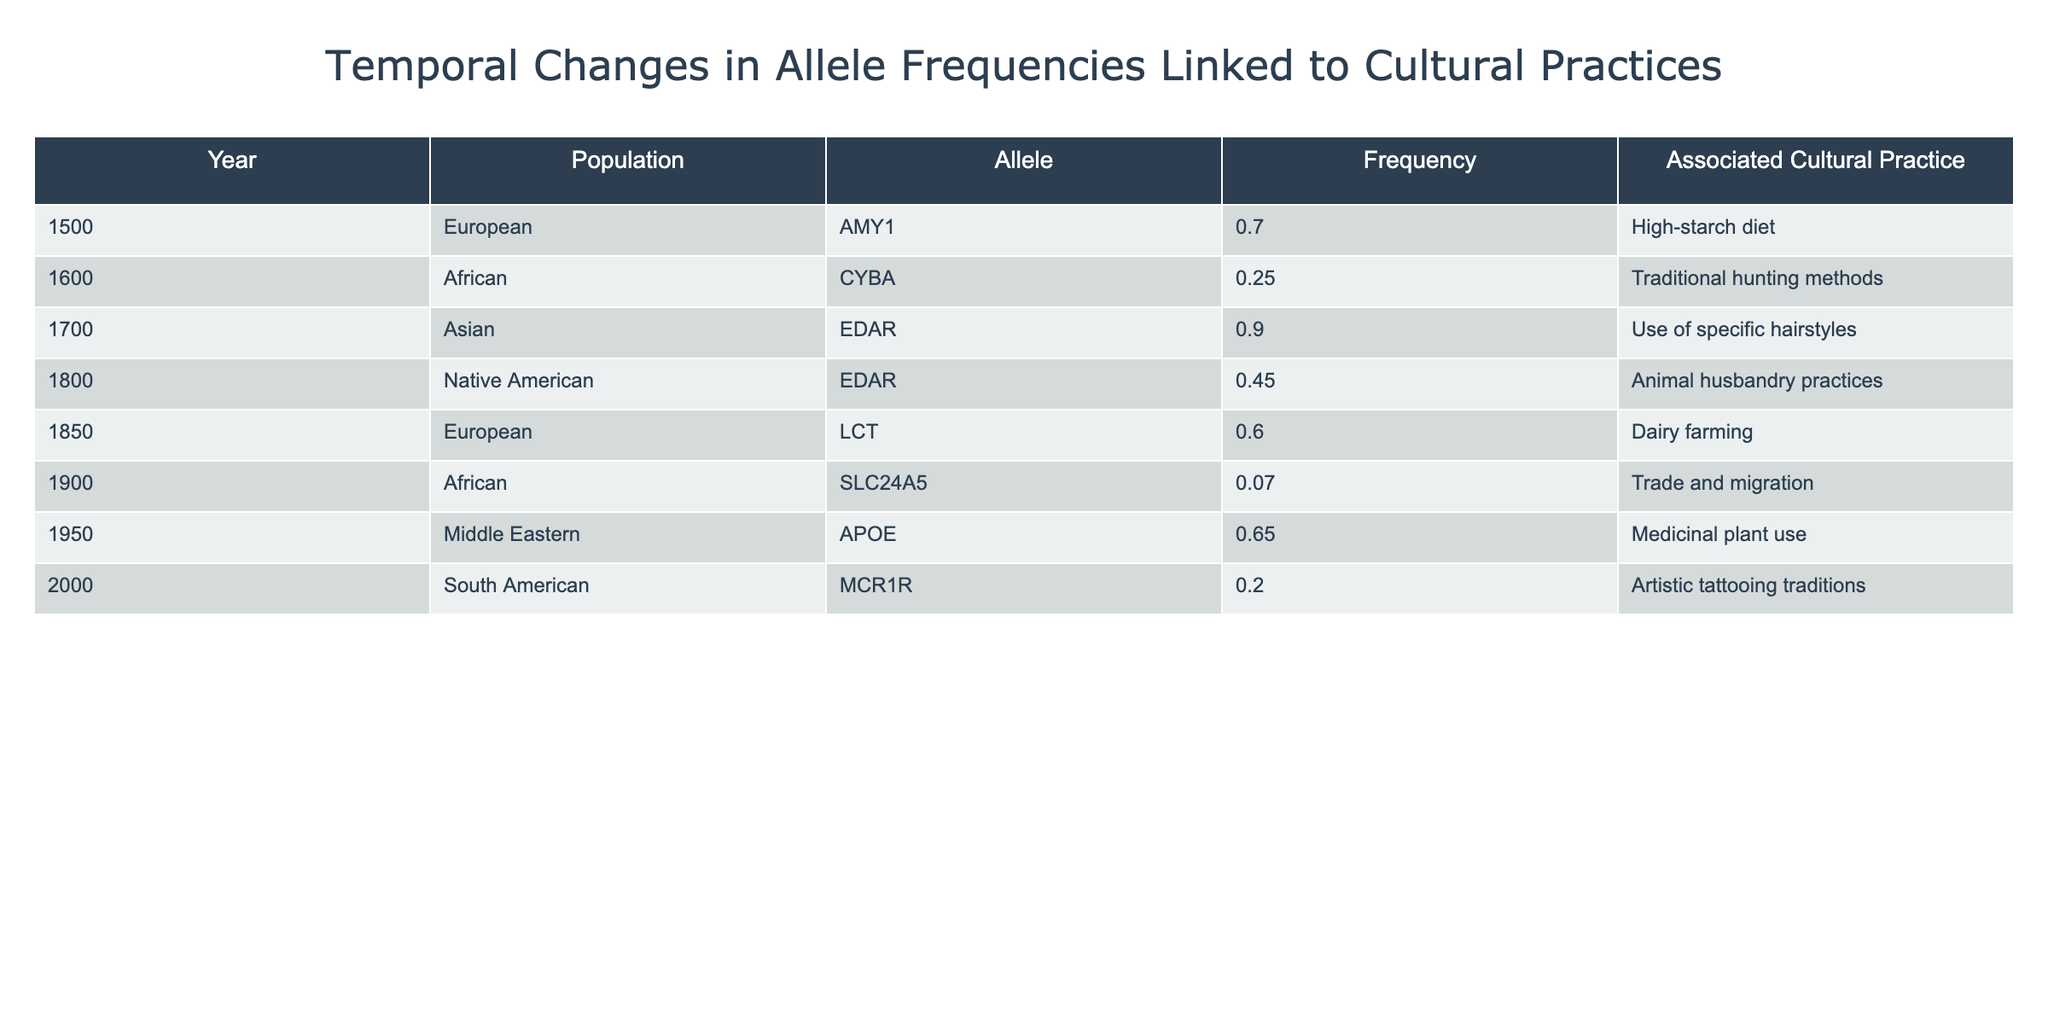What is the allele frequency of AMY1 in the European population in 1500? The table shows that the allele frequency of AMY1 in the European population for the year 1500 is 0.70.
Answer: 0.70 Which cultural practice is associated with the allele CYBA in the African population in 1600? The table indicates that the allele CYBA is associated with traditional hunting methods in the African population in the year 1600.
Answer: Traditional hunting methods What is the frequency of the allele SLC24A5 in the African population in 1900? From the table, the frequency of SLC24A5 in the African population for the year 1900 is 0.07.
Answer: 0.07 What is the average allele frequency of EDAR across the Asian population in 1700 and the Native American population in 1800? The allele frequency of EDAR in the Asian population in 1700 is 0.90, and in the Native American population in 1800, it is 0.45. Adding these gives 0.90 + 0.45 = 1.35. Dividing by 2 (since there are 2 populations) gives an average frequency of 1.35 / 2 = 0.675.
Answer: 0.675 Is the frequency of the allele MCR1R higher in the South American population in 2000 than in the African population in 1900? The table shows that MCR1R has a frequency of 0.20 in the South American population for the year 2000, and SLC24A5 has a frequency of 0.07 in the African population for the year 1900. Since 0.20 is greater than 0.07, the statement is true.
Answer: Yes What is the total frequency of the allele LCT among the European population from the years 1500, 1850, and 1900? The table shows that LCT has a frequency of 0.70 in 1500 and 0.60 in 1850. However, LCT is not listed for 1900, so we only have 0.70 + 0.60 = 1.30 for the two available years. The total frequency is 1.30.
Answer: 1.30 Which population had the highest allele frequency and what was the corresponding allele? Referring to the table, the highest allele frequency is 0.90 associated with the allele EDAR in the Asian population in 1700.
Answer: Asian population, EDAR Was the cultural practice of dairy farming associated with a higher frequency allele than that of animal husbandry practices? The frequency of LCT (associated with dairy farming in the European population in 1850) is 0.60, while the frequency of EDAR (associated with animal husbandry practices in the Native American population in 1800) is 0.45. Since 0.60 is greater than 0.45, the statement is true.
Answer: Yes What is the difference in frequency between the alleles EDAR in the Asian population and APoe in the Middle Eastern population? The frequency of EDAR in the Asian population is 0.90 and the frequency of APOE in the Middle Eastern population is 0.65. To find the difference, subtract 0.65 from 0.90, which gives 0.90 - 0.65 = 0.25.
Answer: 0.25 